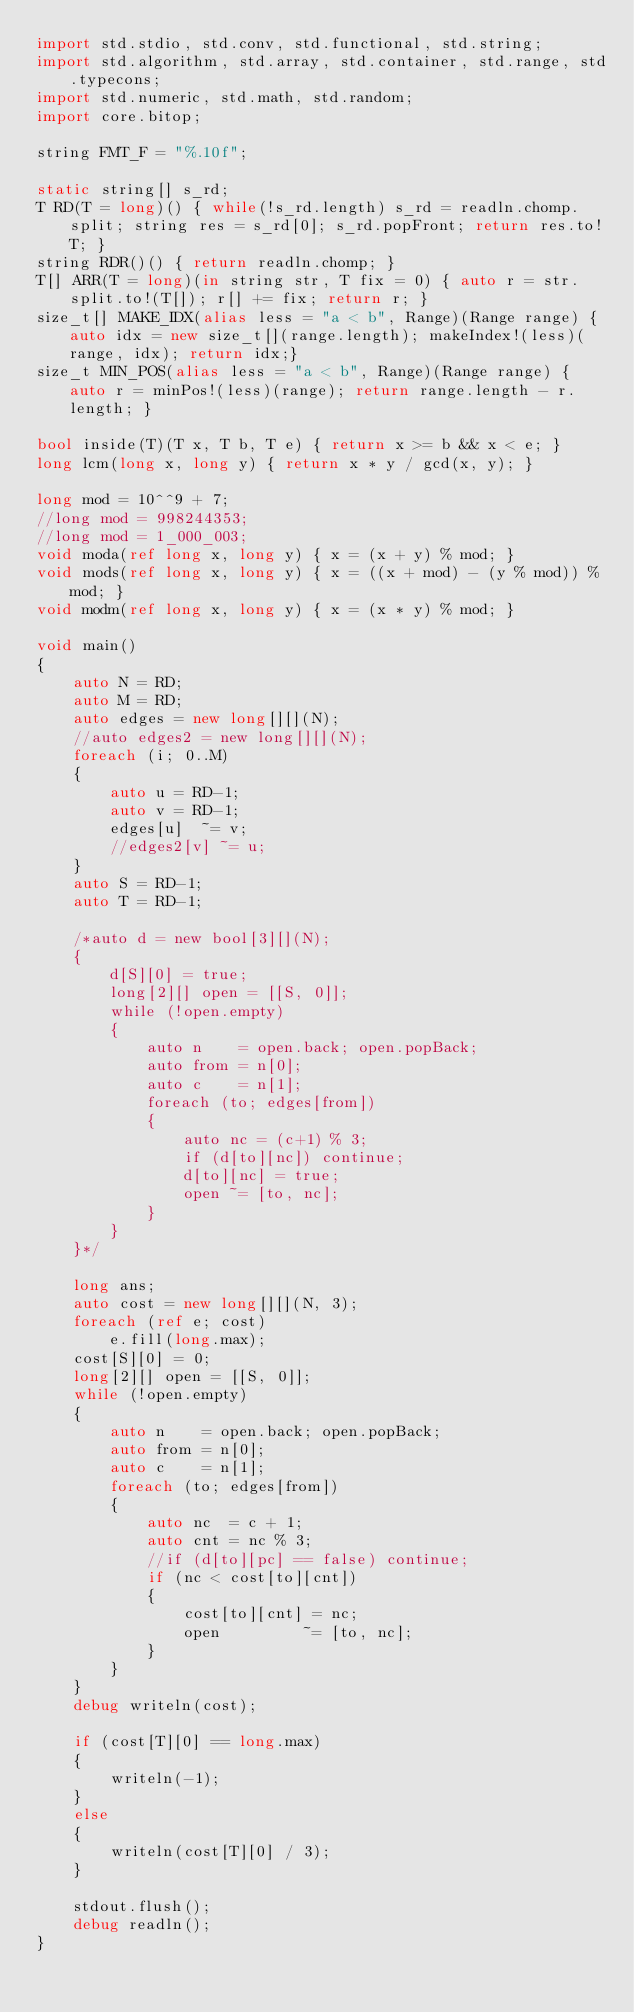Convert code to text. <code><loc_0><loc_0><loc_500><loc_500><_D_>import std.stdio, std.conv, std.functional, std.string;
import std.algorithm, std.array, std.container, std.range, std.typecons;
import std.numeric, std.math, std.random;
import core.bitop;

string FMT_F = "%.10f";

static string[] s_rd;
T RD(T = long)() { while(!s_rd.length) s_rd = readln.chomp.split; string res = s_rd[0]; s_rd.popFront; return res.to!T; }
string RDR()() { return readln.chomp; }
T[] ARR(T = long)(in string str, T fix = 0) { auto r = str.split.to!(T[]); r[] += fix; return r; }
size_t[] MAKE_IDX(alias less = "a < b", Range)(Range range) { auto idx = new size_t[](range.length); makeIndex!(less)(range, idx); return idx;}
size_t MIN_POS(alias less = "a < b", Range)(Range range) { auto r = minPos!(less)(range); return range.length - r.length; }

bool inside(T)(T x, T b, T e) { return x >= b && x < e; }
long lcm(long x, long y) { return x * y / gcd(x, y); }

long mod = 10^^9 + 7;
//long mod = 998244353;
//long mod = 1_000_003;
void moda(ref long x, long y) { x = (x + y) % mod; }
void mods(ref long x, long y) { x = ((x + mod) - (y % mod)) % mod; }
void modm(ref long x, long y) { x = (x * y) % mod; }

void main()
{
	auto N = RD;
	auto M = RD;
	auto edges = new long[][](N);
	//auto edges2 = new long[][](N);
	foreach (i; 0..M)
	{
		auto u = RD-1;
		auto v = RD-1;
		edges[u]  ~= v;
		//edges2[v] ~= u;
	}
	auto S = RD-1;
	auto T = RD-1;

	/*auto d = new bool[3][](N);
	{
		d[S][0] = true;
		long[2][] open = [[S, 0]];
		while (!open.empty)
		{
			auto n    = open.back; open.popBack;
			auto from = n[0];
			auto c    = n[1];
			foreach (to; edges[from])
			{
				auto nc = (c+1) % 3;
				if (d[to][nc]) continue;
				d[to][nc] = true;
				open ~= [to, nc];
			}
		}
	}*/

	long ans;
	auto cost = new long[][](N, 3);
	foreach (ref e; cost)
		e.fill(long.max);
	cost[S][0] = 0;
	long[2][] open = [[S, 0]];
	while (!open.empty)
	{
		auto n    = open.back; open.popBack;
		auto from = n[0];
		auto c    = n[1];
		foreach (to; edges[from])
		{
			auto nc  = c + 1;
			auto cnt = nc % 3;
			//if (d[to][pc] == false) continue;
			if (nc < cost[to][cnt])
			{
				cost[to][cnt] = nc;
				open         ~= [to, nc];
			}
		}
	}
	debug writeln(cost);
	
	if (cost[T][0] == long.max)
	{
		writeln(-1);
	}
	else
	{
		writeln(cost[T][0] / 3);
	}

	stdout.flush();
	debug readln();
}</code> 